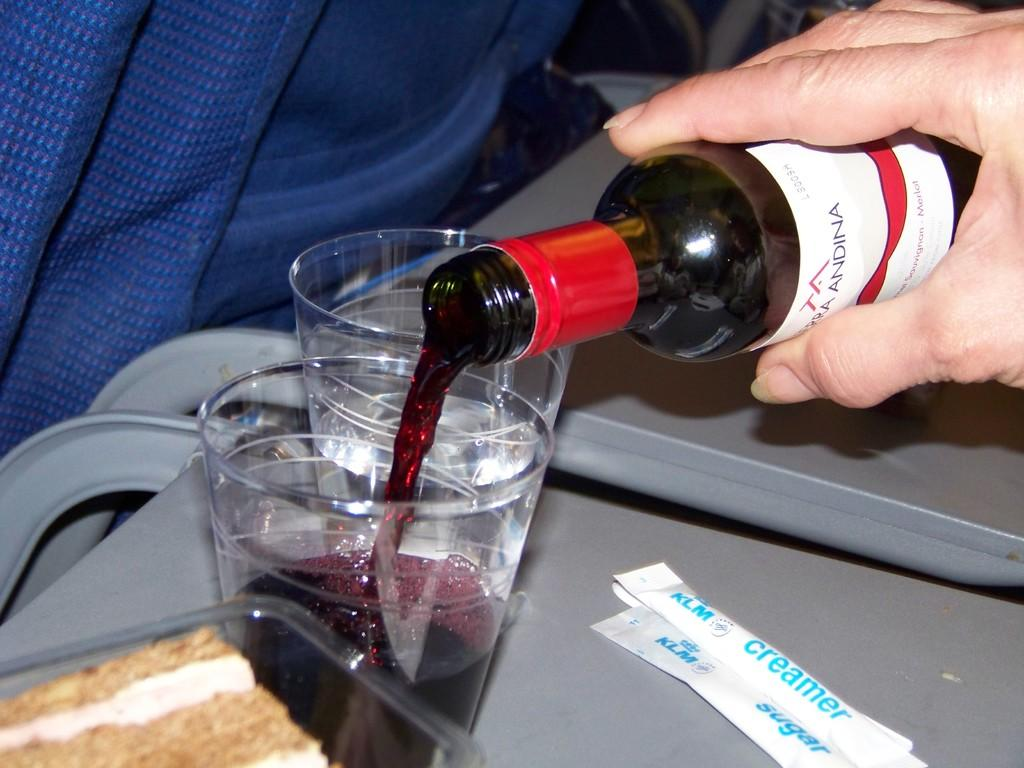<image>
Share a concise interpretation of the image provided. A person is pouring red wine into a plastic glass next to creamer packets. 